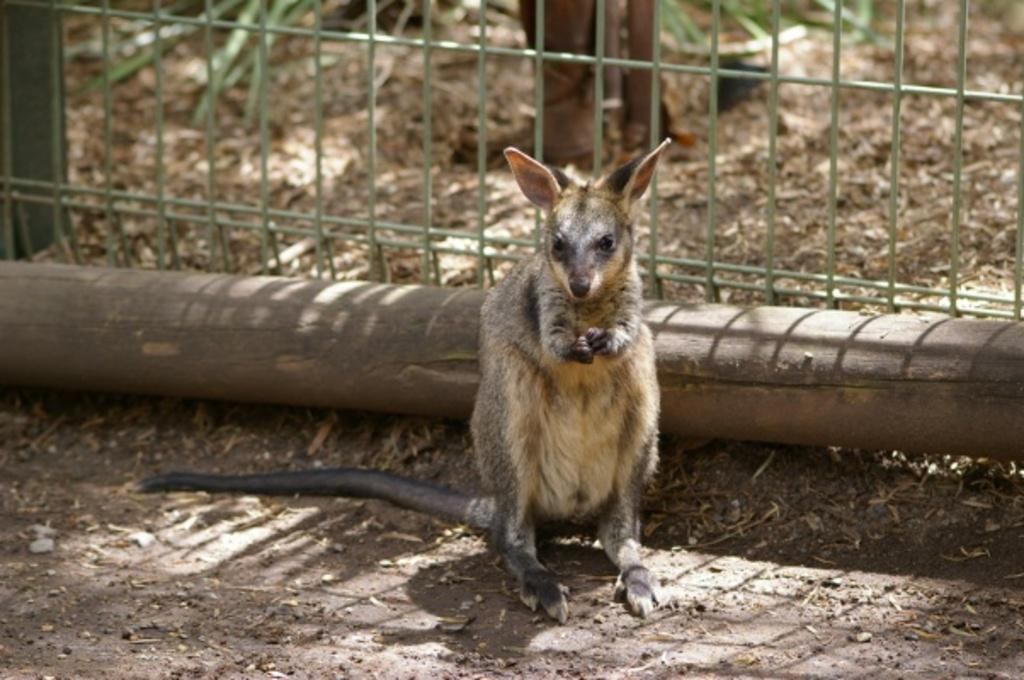What is the main subject in the center of the image? There is an animal in the center of the image. What can be seen in the background of the image? There is a net, sand, plants, and a wooden stick in the background of the image. What is present at the bottom of the image? There are dry leaves and a walkway at the bottom of the image. What type of smile can be seen on the table in the image? There is no table or smile present in the image. 